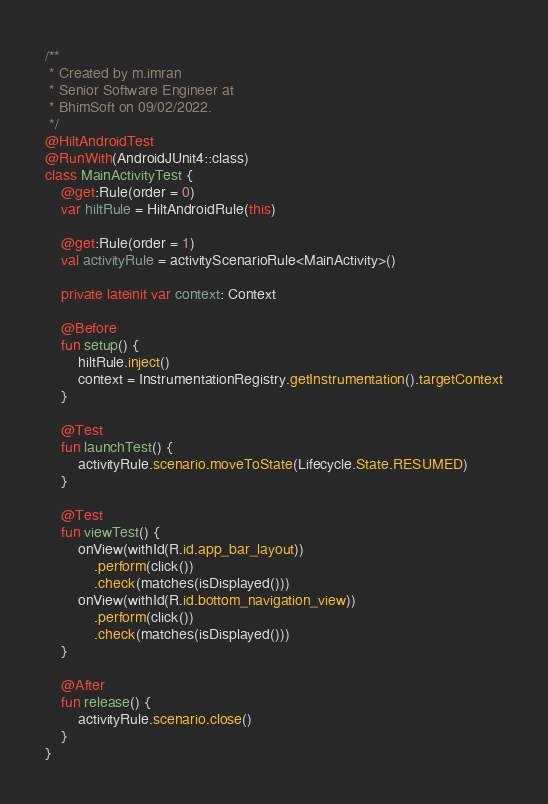Convert code to text. <code><loc_0><loc_0><loc_500><loc_500><_Kotlin_>/**
 * Created by m.imran
 * Senior Software Engineer at
 * BhimSoft on 09/02/2022.
 */
@HiltAndroidTest
@RunWith(AndroidJUnit4::class)
class MainActivityTest {
    @get:Rule(order = 0)
    var hiltRule = HiltAndroidRule(this)

    @get:Rule(order = 1)
    val activityRule = activityScenarioRule<MainActivity>()

    private lateinit var context: Context

    @Before
    fun setup() {
        hiltRule.inject()
        context = InstrumentationRegistry.getInstrumentation().targetContext
    }

    @Test
    fun launchTest() {
        activityRule.scenario.moveToState(Lifecycle.State.RESUMED)
    }

    @Test
    fun viewTest() {
        onView(withId(R.id.app_bar_layout))
            .perform(click())
            .check(matches(isDisplayed()))
        onView(withId(R.id.bottom_navigation_view))
            .perform(click())
            .check(matches(isDisplayed()))
    }

    @After
    fun release() {
        activityRule.scenario.close()
    }
}</code> 